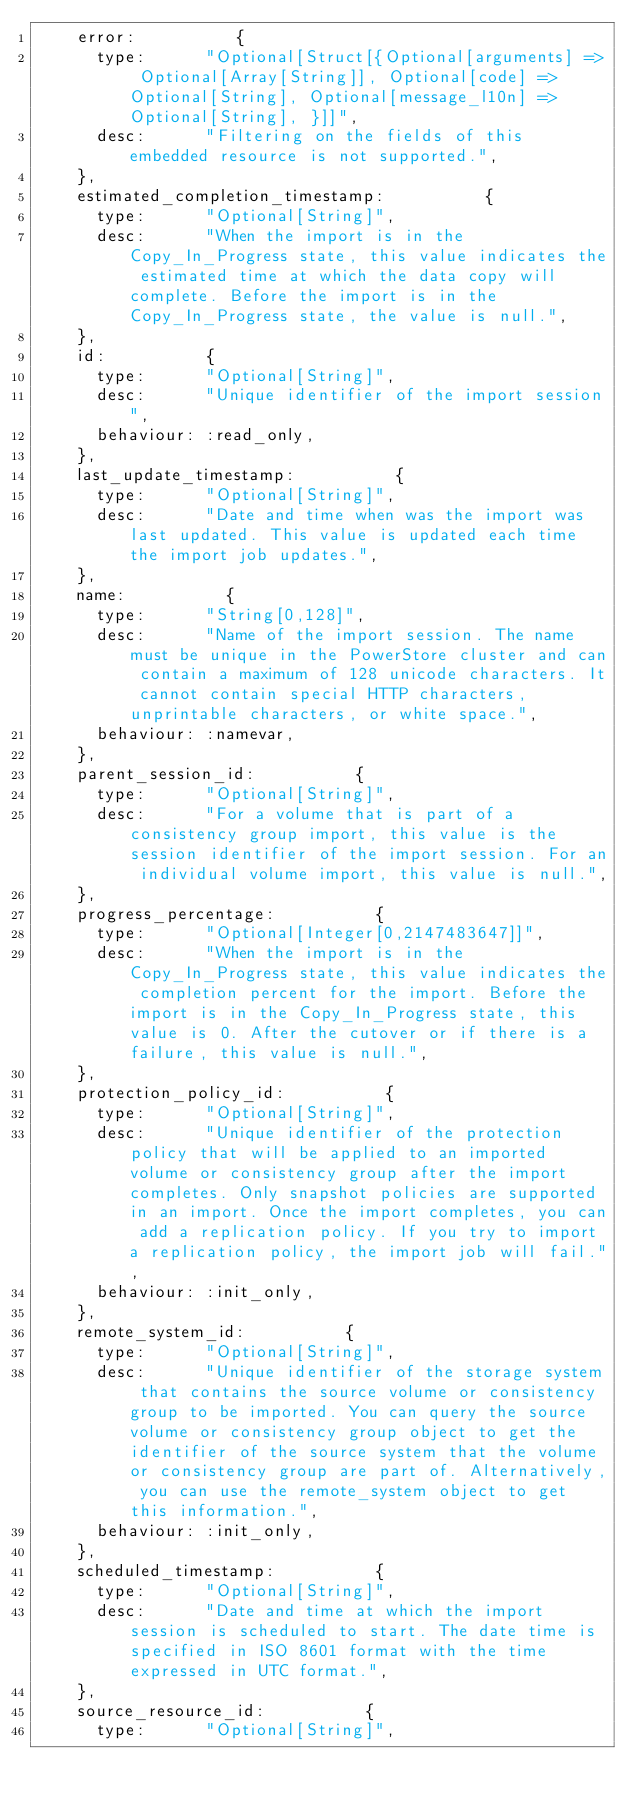<code> <loc_0><loc_0><loc_500><loc_500><_Ruby_>    error:          {
      type:      "Optional[Struct[{Optional[arguments] => Optional[Array[String]], Optional[code] => Optional[String], Optional[message_l10n] => Optional[String], }]]",
      desc:      "Filtering on the fields of this embedded resource is not supported.",
    },
    estimated_completion_timestamp:          {
      type:      "Optional[String]",
      desc:      "When the import is in the Copy_In_Progress state, this value indicates the estimated time at which the data copy will complete. Before the import is in the Copy_In_Progress state, the value is null.",
    },
    id:          {
      type:      "Optional[String]",
      desc:      "Unique identifier of the import session",
      behaviour: :read_only,
    },
    last_update_timestamp:          {
      type:      "Optional[String]",
      desc:      "Date and time when was the import was last updated. This value is updated each time the import job updates.",
    },
    name:          {
      type:      "String[0,128]",
      desc:      "Name of the import session. The name must be unique in the PowerStore cluster and can contain a maximum of 128 unicode characters. It cannot contain special HTTP characters, unprintable characters, or white space.",
      behaviour: :namevar,
    },
    parent_session_id:          {
      type:      "Optional[String]",
      desc:      "For a volume that is part of a consistency group import, this value is the session identifier of the import session. For an individual volume import, this value is null.",
    },
    progress_percentage:          {
      type:      "Optional[Integer[0,2147483647]]",
      desc:      "When the import is in the Copy_In_Progress state, this value indicates the completion percent for the import. Before the import is in the Copy_In_Progress state, this value is 0. After the cutover or if there is a failure, this value is null.",
    },
    protection_policy_id:          {
      type:      "Optional[String]",
      desc:      "Unique identifier of the protection policy that will be applied to an imported volume or consistency group after the import completes. Only snapshot policies are supported in an import. Once the import completes, you can add a replication policy. If you try to import a replication policy, the import job will fail.",
      behaviour: :init_only,
    },
    remote_system_id:          {
      type:      "Optional[String]",
      desc:      "Unique identifier of the storage system that contains the source volume or consistency group to be imported. You can query the source volume or consistency group object to get the identifier of the source system that the volume or consistency group are part of. Alternatively, you can use the remote_system object to get this information.",
      behaviour: :init_only,
    },
    scheduled_timestamp:          {
      type:      "Optional[String]",
      desc:      "Date and time at which the import session is scheduled to start. The date time is specified in ISO 8601 format with the time expressed in UTC format.",
    },
    source_resource_id:          {
      type:      "Optional[String]",</code> 